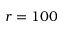Convert formula to latex. <formula><loc_0><loc_0><loc_500><loc_500>r = 1 0 0</formula> 